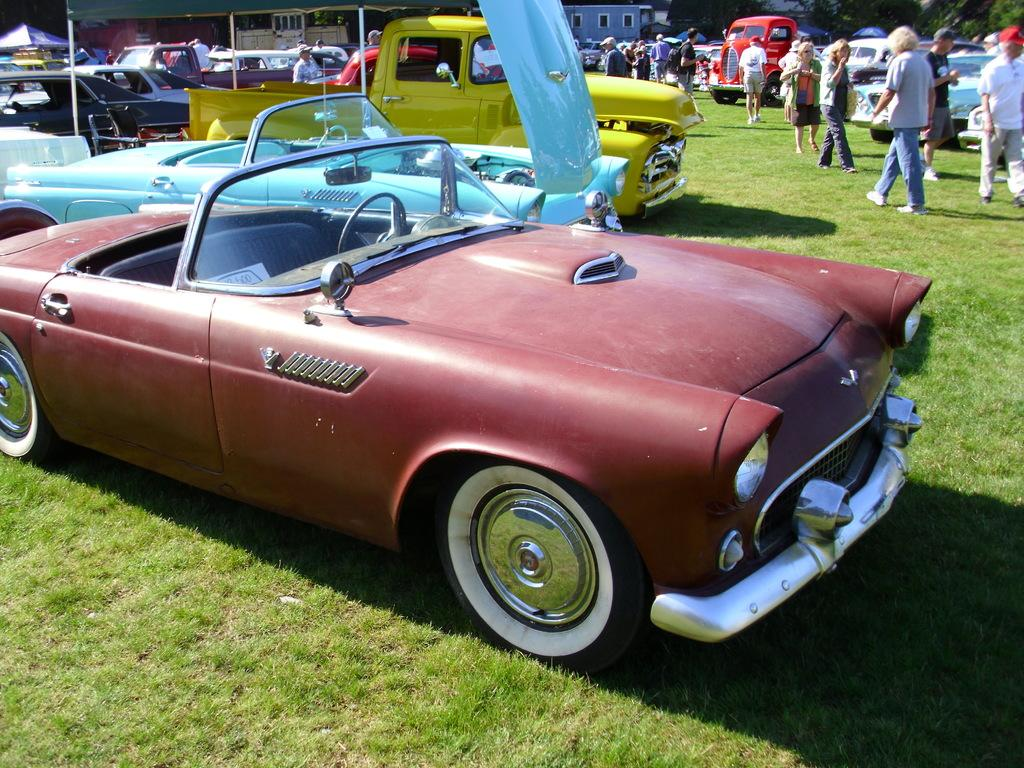Who or what is present in the image? There are people in the image. What is an unusual location for the cars in the image? There are cars on the grass in the image. What type of structures can be seen in the image? There are buildings in the image. What objects are present that might be used for support or signage? There are poles in the image. What historical event is being commemorated by the people in the image? There is no indication of a historical event or war in the image. What discovery was made by the people in the image? There is no discovery mentioned or depicted in the image. 